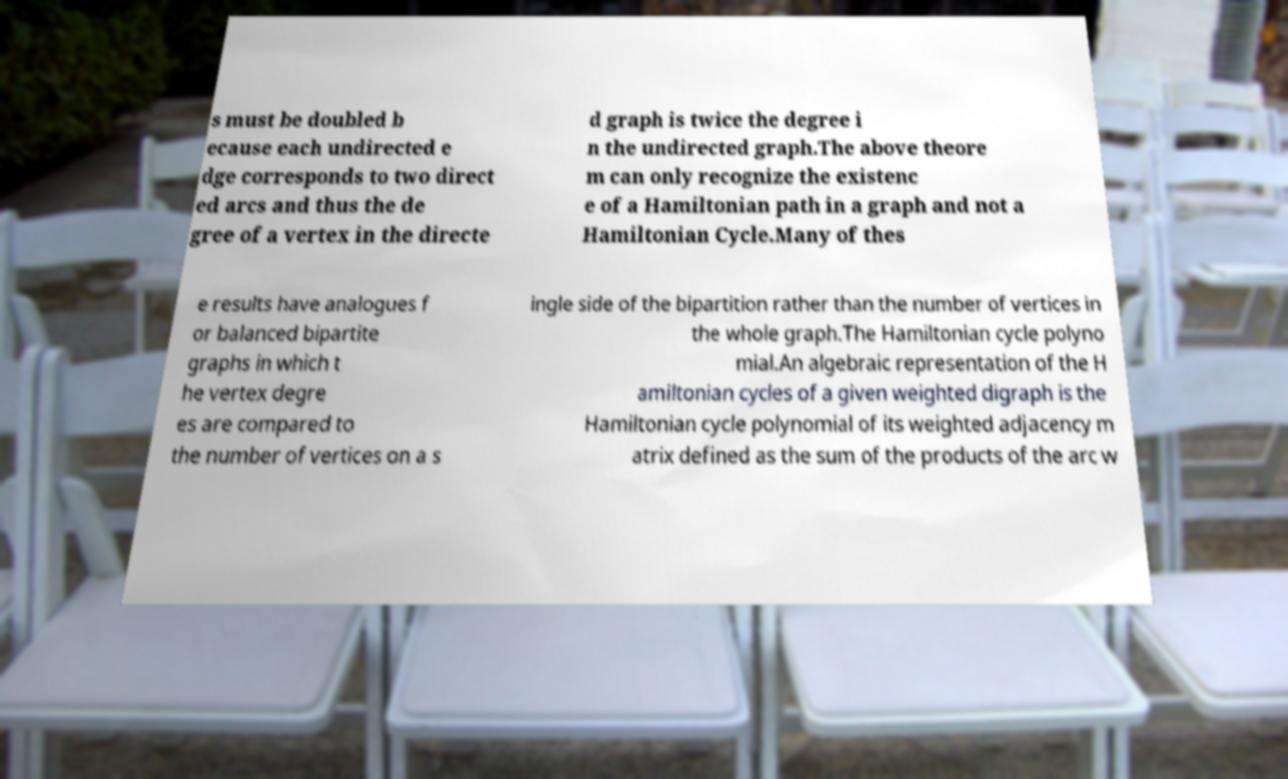I need the written content from this picture converted into text. Can you do that? s must be doubled b ecause each undirected e dge corresponds to two direct ed arcs and thus the de gree of a vertex in the directe d graph is twice the degree i n the undirected graph.The above theore m can only recognize the existenc e of a Hamiltonian path in a graph and not a Hamiltonian Cycle.Many of thes e results have analogues f or balanced bipartite graphs in which t he vertex degre es are compared to the number of vertices on a s ingle side of the bipartition rather than the number of vertices in the whole graph.The Hamiltonian cycle polyno mial.An algebraic representation of the H amiltonian cycles of a given weighted digraph is the Hamiltonian cycle polynomial of its weighted adjacency m atrix defined as the sum of the products of the arc w 